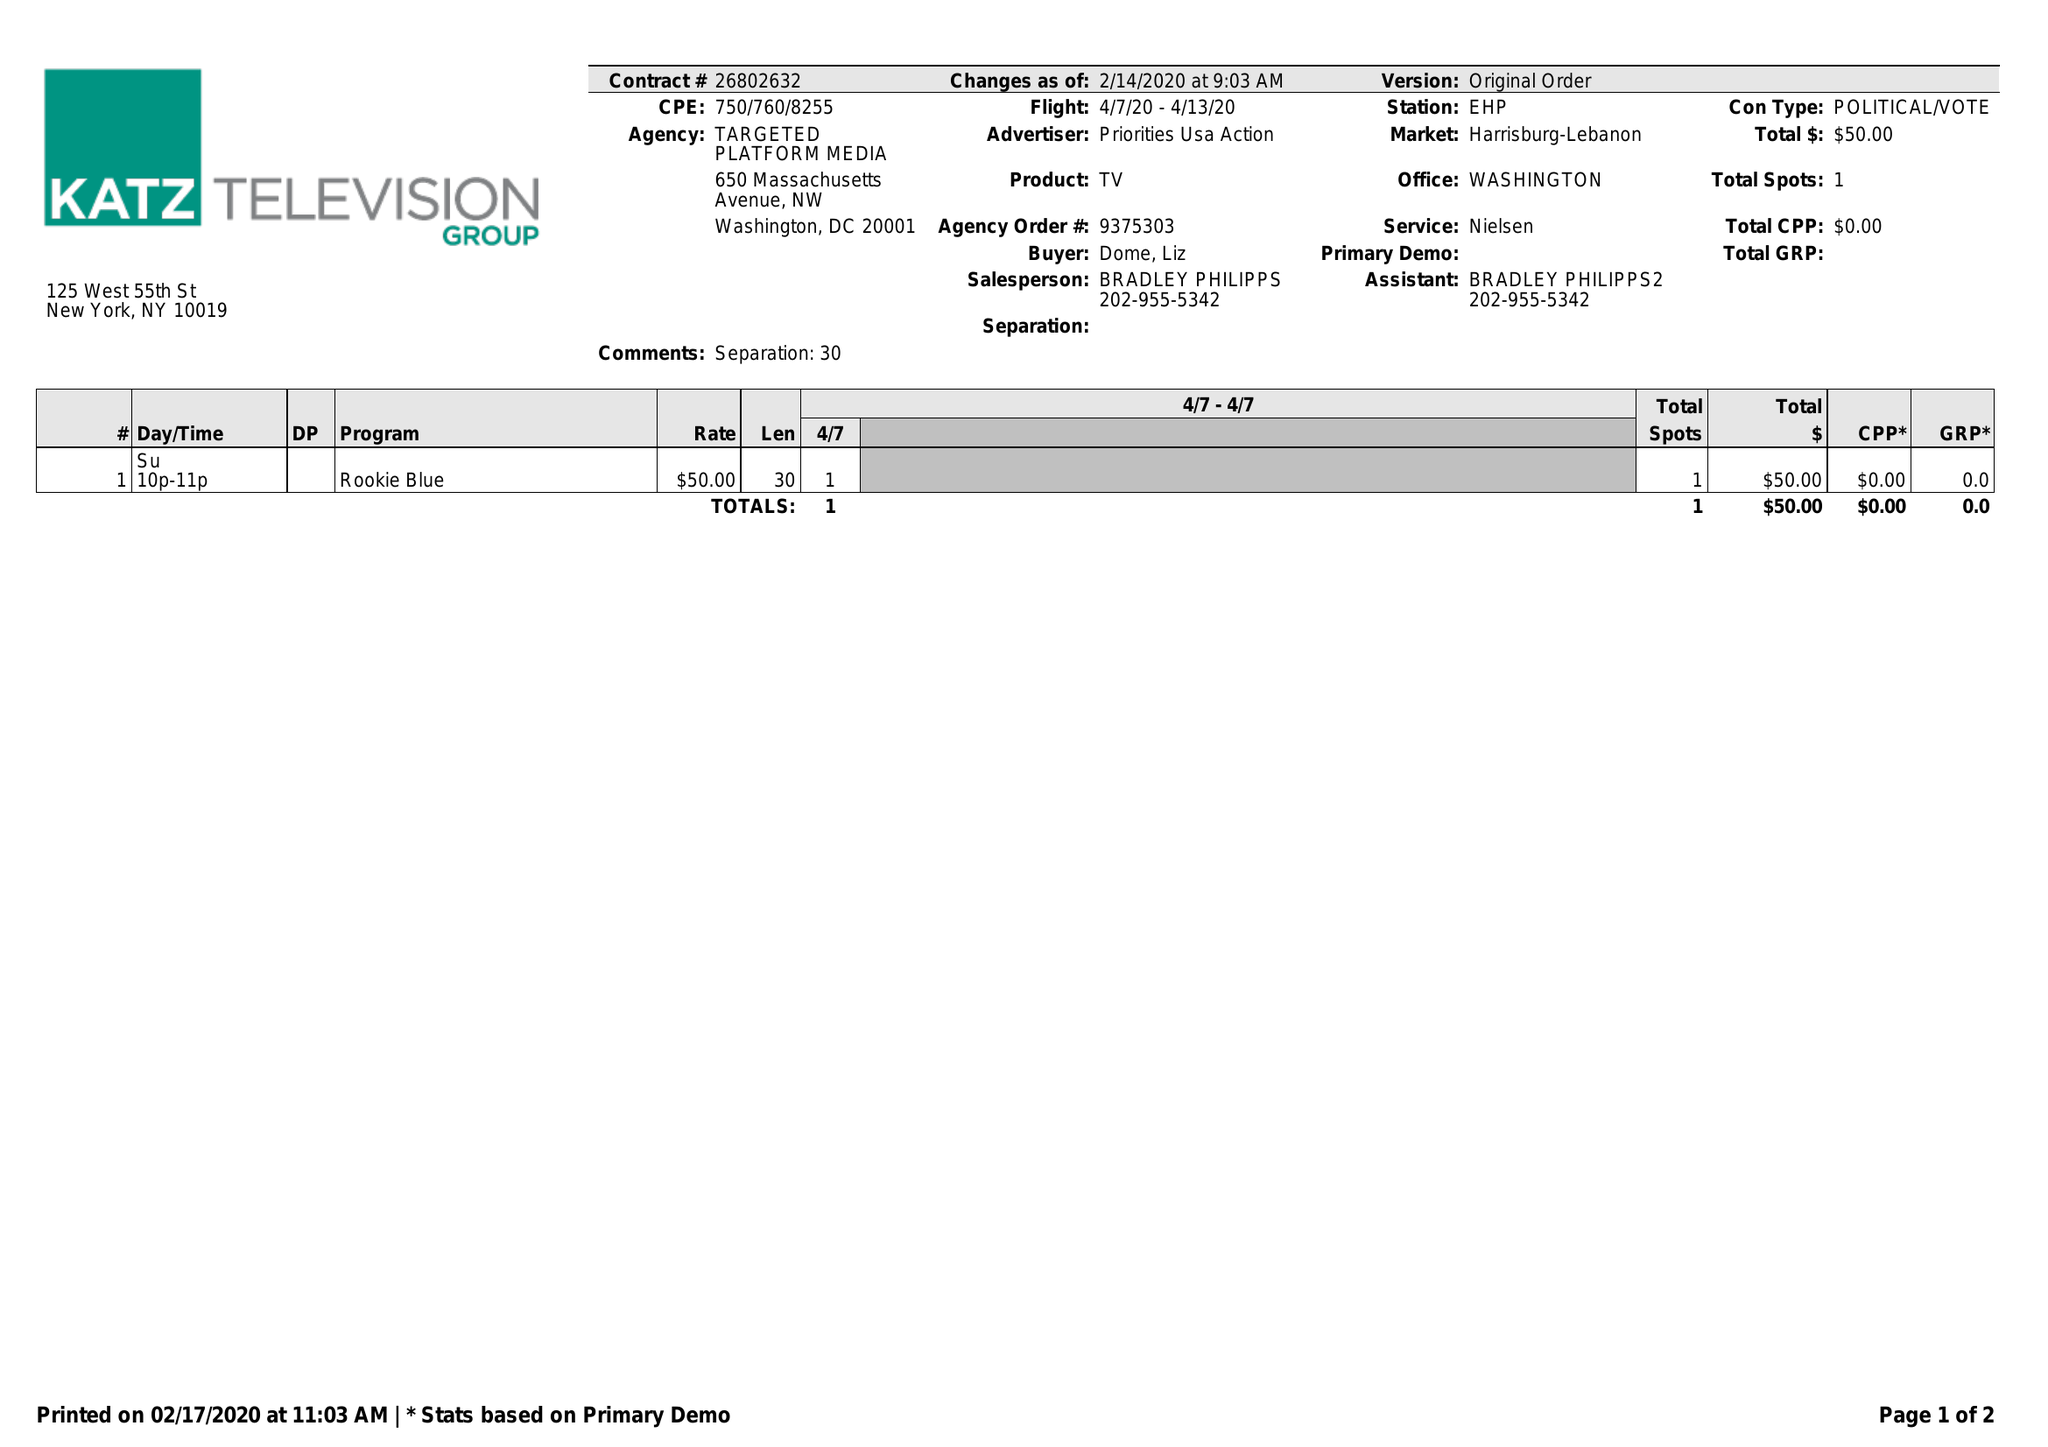What is the value for the flight_to?
Answer the question using a single word or phrase. 04/13/20 